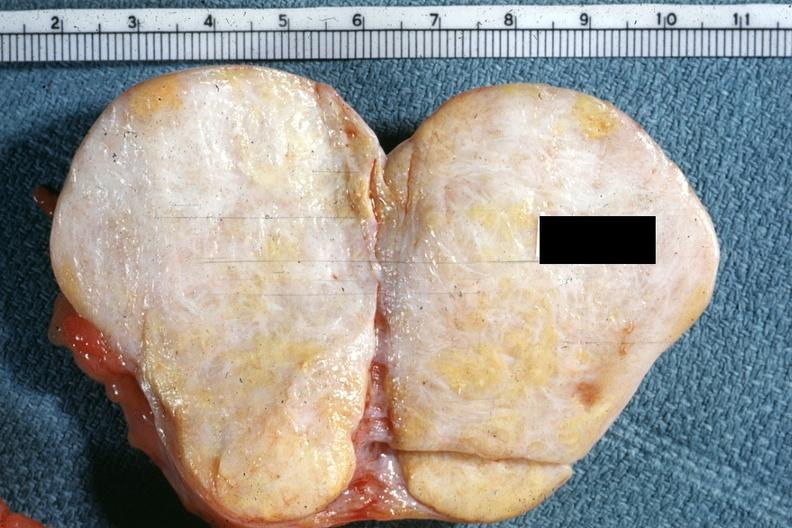what is there to indicate the location of the tumor mass?
Answer the question using a single word or phrase. No ovary present 